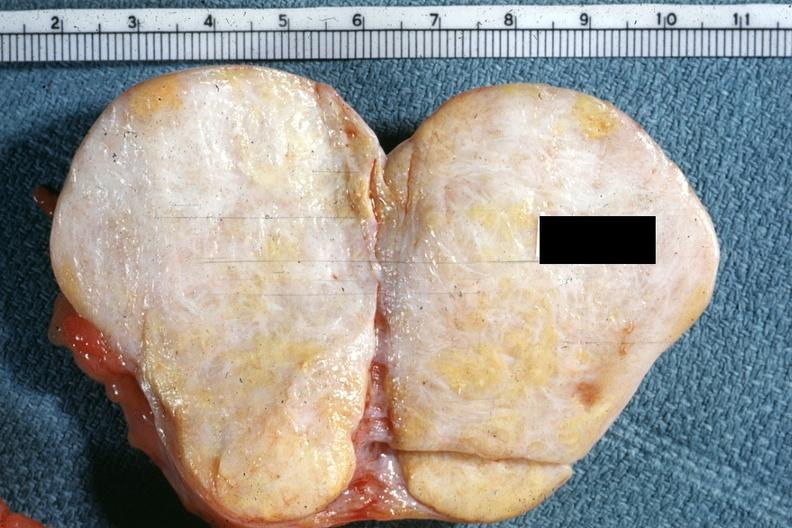what is there to indicate the location of the tumor mass?
Answer the question using a single word or phrase. No ovary present 